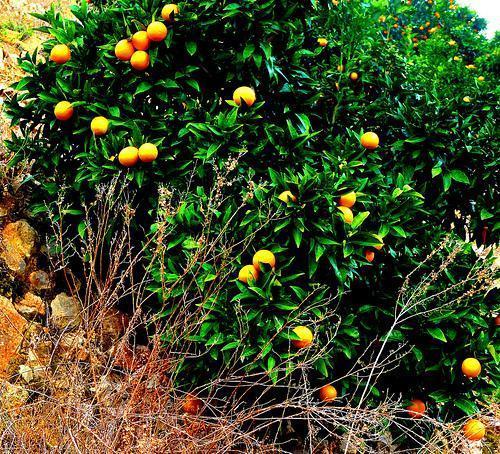How many bushes are there?
Give a very brief answer. 1. 